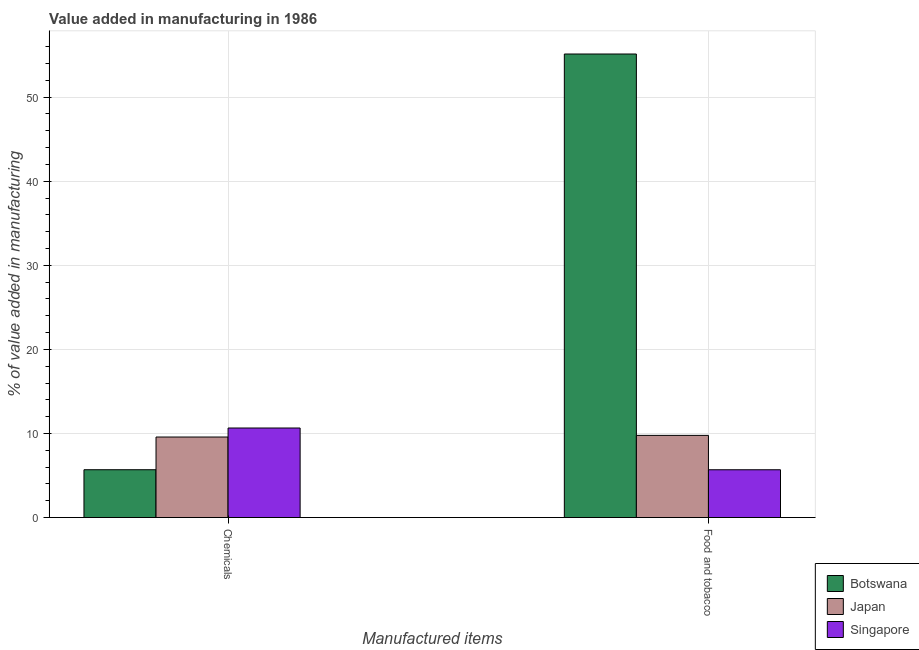How many groups of bars are there?
Make the answer very short. 2. How many bars are there on the 2nd tick from the left?
Keep it short and to the point. 3. What is the label of the 1st group of bars from the left?
Your response must be concise. Chemicals. What is the value added by manufacturing food and tobacco in Singapore?
Your answer should be compact. 5.68. Across all countries, what is the maximum value added by  manufacturing chemicals?
Provide a succinct answer. 10.65. Across all countries, what is the minimum value added by manufacturing food and tobacco?
Ensure brevity in your answer.  5.68. In which country was the value added by manufacturing food and tobacco maximum?
Provide a succinct answer. Botswana. In which country was the value added by  manufacturing chemicals minimum?
Offer a very short reply. Botswana. What is the total value added by manufacturing food and tobacco in the graph?
Make the answer very short. 70.59. What is the difference between the value added by manufacturing food and tobacco in Singapore and that in Japan?
Offer a terse response. -4.09. What is the difference between the value added by manufacturing food and tobacco in Botswana and the value added by  manufacturing chemicals in Singapore?
Your answer should be compact. 44.48. What is the average value added by manufacturing food and tobacco per country?
Your response must be concise. 23.53. What is the difference between the value added by manufacturing food and tobacco and value added by  manufacturing chemicals in Japan?
Make the answer very short. 0.19. What is the ratio of the value added by manufacturing food and tobacco in Singapore to that in Japan?
Provide a succinct answer. 0.58. Is the value added by manufacturing food and tobacco in Singapore less than that in Japan?
Offer a terse response. Yes. What does the 1st bar from the left in Food and tobacco represents?
Your response must be concise. Botswana. Are the values on the major ticks of Y-axis written in scientific E-notation?
Make the answer very short. No. How many legend labels are there?
Offer a very short reply. 3. How are the legend labels stacked?
Your answer should be very brief. Vertical. What is the title of the graph?
Your response must be concise. Value added in manufacturing in 1986. Does "Sweden" appear as one of the legend labels in the graph?
Your response must be concise. No. What is the label or title of the X-axis?
Make the answer very short. Manufactured items. What is the label or title of the Y-axis?
Your answer should be very brief. % of value added in manufacturing. What is the % of value added in manufacturing of Botswana in Chemicals?
Keep it short and to the point. 5.69. What is the % of value added in manufacturing of Japan in Chemicals?
Give a very brief answer. 9.58. What is the % of value added in manufacturing in Singapore in Chemicals?
Offer a terse response. 10.65. What is the % of value added in manufacturing in Botswana in Food and tobacco?
Your answer should be very brief. 55.13. What is the % of value added in manufacturing of Japan in Food and tobacco?
Provide a succinct answer. 9.77. What is the % of value added in manufacturing of Singapore in Food and tobacco?
Provide a short and direct response. 5.68. Across all Manufactured items, what is the maximum % of value added in manufacturing in Botswana?
Your answer should be compact. 55.13. Across all Manufactured items, what is the maximum % of value added in manufacturing of Japan?
Your response must be concise. 9.77. Across all Manufactured items, what is the maximum % of value added in manufacturing of Singapore?
Your answer should be very brief. 10.65. Across all Manufactured items, what is the minimum % of value added in manufacturing of Botswana?
Your response must be concise. 5.69. Across all Manufactured items, what is the minimum % of value added in manufacturing in Japan?
Provide a short and direct response. 9.58. Across all Manufactured items, what is the minimum % of value added in manufacturing of Singapore?
Provide a short and direct response. 5.68. What is the total % of value added in manufacturing in Botswana in the graph?
Offer a very short reply. 60.82. What is the total % of value added in manufacturing of Japan in the graph?
Make the answer very short. 19.35. What is the total % of value added in manufacturing of Singapore in the graph?
Provide a short and direct response. 16.34. What is the difference between the % of value added in manufacturing of Botswana in Chemicals and that in Food and tobacco?
Provide a succinct answer. -49.44. What is the difference between the % of value added in manufacturing in Japan in Chemicals and that in Food and tobacco?
Your answer should be very brief. -0.2. What is the difference between the % of value added in manufacturing in Singapore in Chemicals and that in Food and tobacco?
Offer a terse response. 4.97. What is the difference between the % of value added in manufacturing in Botswana in Chemicals and the % of value added in manufacturing in Japan in Food and tobacco?
Make the answer very short. -4.08. What is the difference between the % of value added in manufacturing of Botswana in Chemicals and the % of value added in manufacturing of Singapore in Food and tobacco?
Offer a very short reply. 0. What is the difference between the % of value added in manufacturing in Japan in Chemicals and the % of value added in manufacturing in Singapore in Food and tobacco?
Provide a succinct answer. 3.89. What is the average % of value added in manufacturing of Botswana per Manufactured items?
Make the answer very short. 30.41. What is the average % of value added in manufacturing of Japan per Manufactured items?
Make the answer very short. 9.68. What is the average % of value added in manufacturing of Singapore per Manufactured items?
Keep it short and to the point. 8.17. What is the difference between the % of value added in manufacturing of Botswana and % of value added in manufacturing of Japan in Chemicals?
Ensure brevity in your answer.  -3.89. What is the difference between the % of value added in manufacturing of Botswana and % of value added in manufacturing of Singapore in Chemicals?
Ensure brevity in your answer.  -4.96. What is the difference between the % of value added in manufacturing of Japan and % of value added in manufacturing of Singapore in Chemicals?
Make the answer very short. -1.07. What is the difference between the % of value added in manufacturing in Botswana and % of value added in manufacturing in Japan in Food and tobacco?
Provide a succinct answer. 45.36. What is the difference between the % of value added in manufacturing in Botswana and % of value added in manufacturing in Singapore in Food and tobacco?
Make the answer very short. 49.44. What is the difference between the % of value added in manufacturing in Japan and % of value added in manufacturing in Singapore in Food and tobacco?
Offer a very short reply. 4.09. What is the ratio of the % of value added in manufacturing of Botswana in Chemicals to that in Food and tobacco?
Ensure brevity in your answer.  0.1. What is the ratio of the % of value added in manufacturing in Japan in Chemicals to that in Food and tobacco?
Provide a short and direct response. 0.98. What is the ratio of the % of value added in manufacturing of Singapore in Chemicals to that in Food and tobacco?
Provide a short and direct response. 1.87. What is the difference between the highest and the second highest % of value added in manufacturing in Botswana?
Offer a very short reply. 49.44. What is the difference between the highest and the second highest % of value added in manufacturing of Japan?
Your response must be concise. 0.2. What is the difference between the highest and the second highest % of value added in manufacturing in Singapore?
Make the answer very short. 4.97. What is the difference between the highest and the lowest % of value added in manufacturing in Botswana?
Provide a succinct answer. 49.44. What is the difference between the highest and the lowest % of value added in manufacturing of Japan?
Offer a terse response. 0.2. What is the difference between the highest and the lowest % of value added in manufacturing in Singapore?
Your response must be concise. 4.97. 